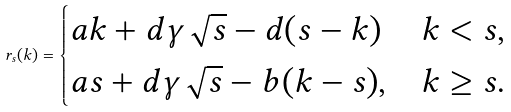<formula> <loc_0><loc_0><loc_500><loc_500>r _ { s } ( k ) = \begin{cases} a k + d \gamma \sqrt { s } - d ( s - k ) & k < s , \\ a s + d \gamma \sqrt { s } - b ( k - s ) , & k \geq s . \\ \end{cases}</formula> 